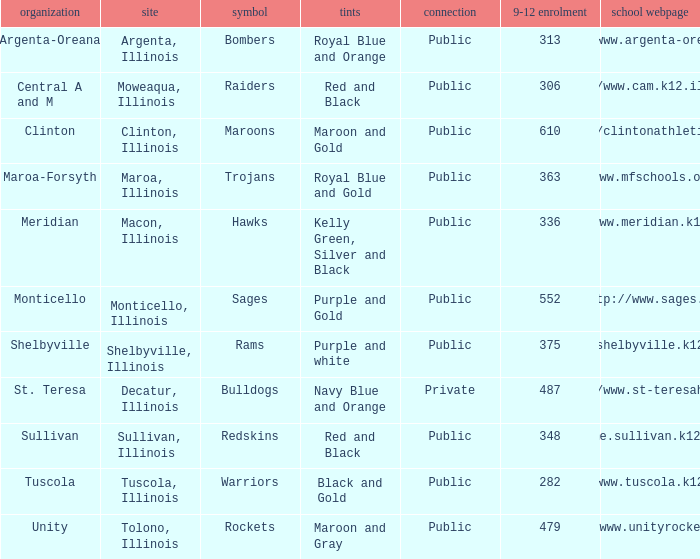What's the name of the city or town of the school that operates the http://www.mfschools.org/high/ website? Maroa-Forsyth. 